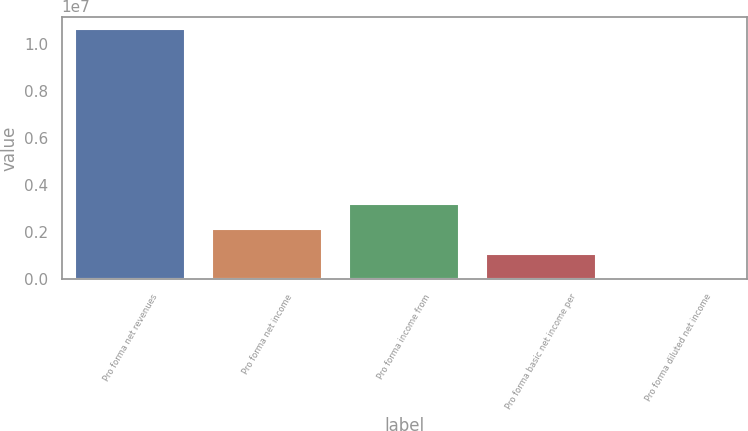Convert chart to OTSL. <chart><loc_0><loc_0><loc_500><loc_500><bar_chart><fcel>Pro forma net revenues<fcel>Pro forma net income<fcel>Pro forma income from<fcel>Pro forma basic net income per<fcel>Pro forma diluted net income<nl><fcel>1.06364e+07<fcel>2.12728e+06<fcel>3.19092e+06<fcel>1.06364e+06<fcel>7.91<nl></chart> 